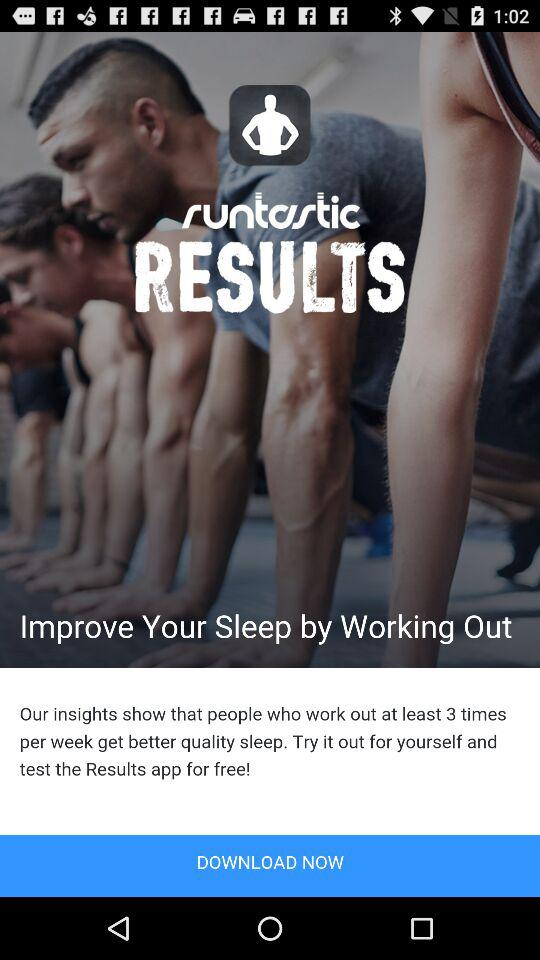What type of people get better quality sleep? People who work out at least 3 times per week get better quality sleep. 